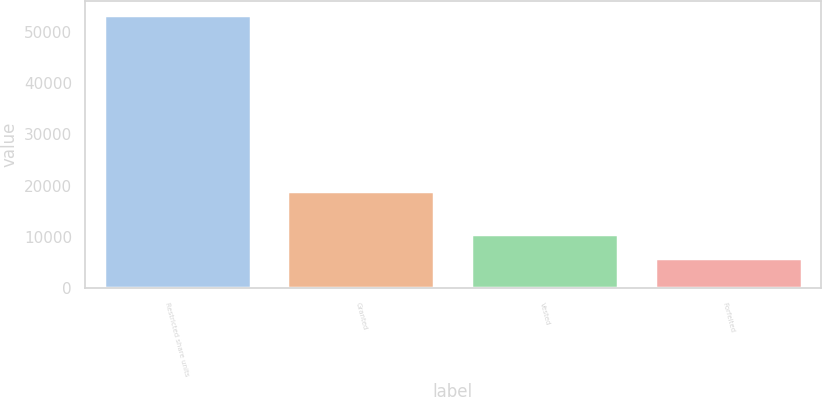<chart> <loc_0><loc_0><loc_500><loc_500><bar_chart><fcel>Restricted share units<fcel>Granted<fcel>Vested<fcel>Forfeited<nl><fcel>53297.2<fcel>19070<fcel>10659.2<fcel>5940<nl></chart> 